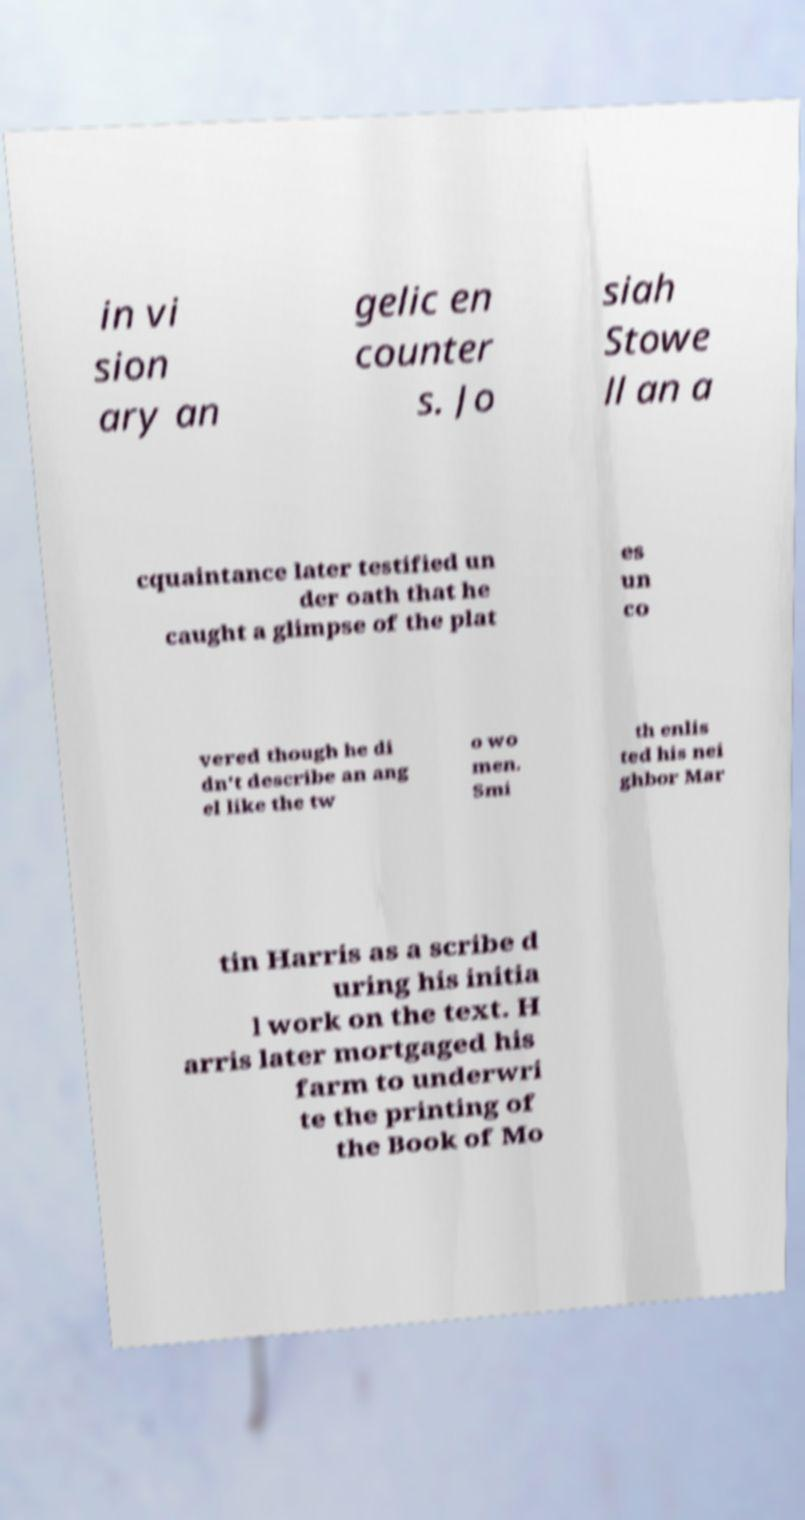Can you accurately transcribe the text from the provided image for me? in vi sion ary an gelic en counter s. Jo siah Stowe ll an a cquaintance later testified un der oath that he caught a glimpse of the plat es un co vered though he di dn't describe an ang el like the tw o wo men. Smi th enlis ted his nei ghbor Mar tin Harris as a scribe d uring his initia l work on the text. H arris later mortgaged his farm to underwri te the printing of the Book of Mo 